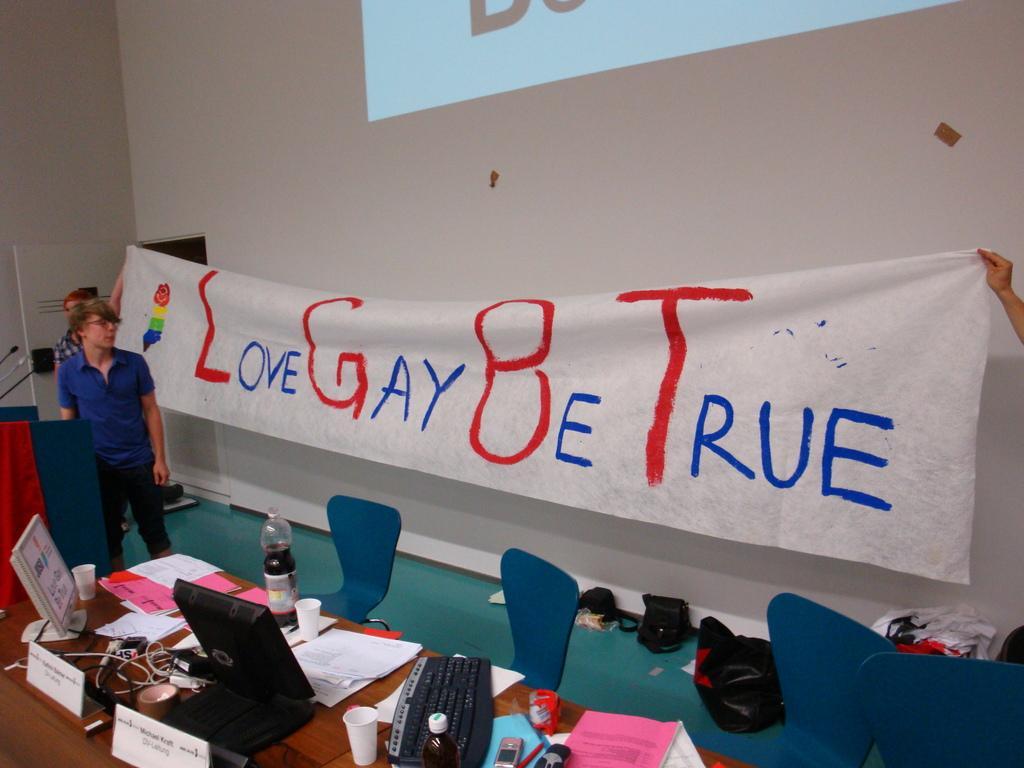In one or two sentences, can you explain what this image depicts? In this image I can see some objects on the table. I can see the chairs. I can see some objects on the floor. In the background, I can a cloth with some text on it. I can see the wall. 